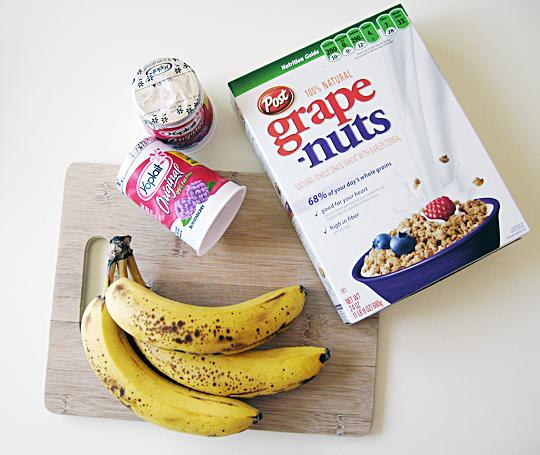What are grape nuts?
Write a very short answer. Cereal. What are the bananas lying on?
Give a very brief answer. Cutting board. What type of yogurt is shown?
Write a very short answer. Yoplait. 